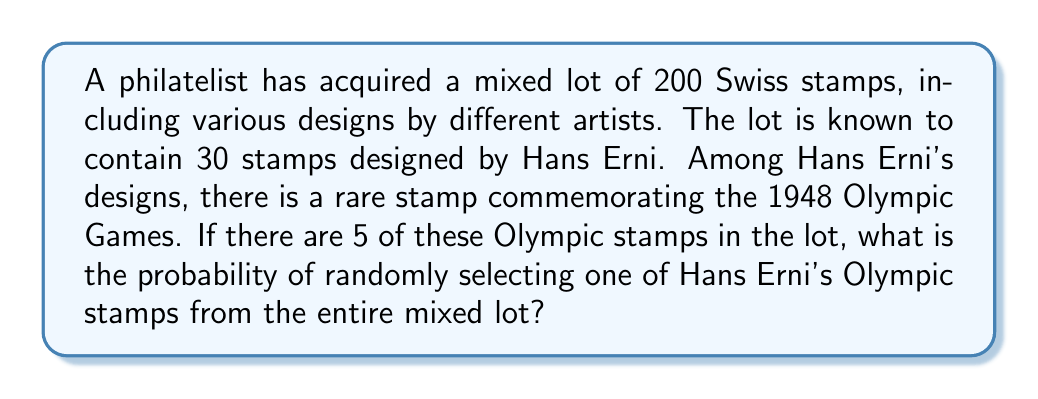What is the answer to this math problem? To solve this problem, we need to use the concept of probability. The probability of an event is calculated by dividing the number of favorable outcomes by the total number of possible outcomes.

Let's break down the given information:
1. Total number of stamps in the lot: 200
2. Number of Hans Erni stamps: 30
3. Number of Hans Erni's Olympic stamps: 5

To find the probability of randomly selecting one of Hans Erni's Olympic stamps, we use the formula:

$$ P(\text{Olympic stamp}) = \frac{\text{Number of Olympic stamps}}{\text{Total number of stamps}} $$

Substituting the values:

$$ P(\text{Olympic stamp}) = \frac{5}{200} $$

To simplify this fraction, we can divide both the numerator and denominator by 5:

$$ P(\text{Olympic stamp}) = \frac{5 \div 5}{200 \div 5} = \frac{1}{40} $$

Therefore, the probability of randomly selecting one of Hans Erni's Olympic stamps from the entire mixed lot is $\frac{1}{40}$ or 0.025 or 2.5%.
Answer: $\frac{1}{40}$ or 0.025 or 2.5% 